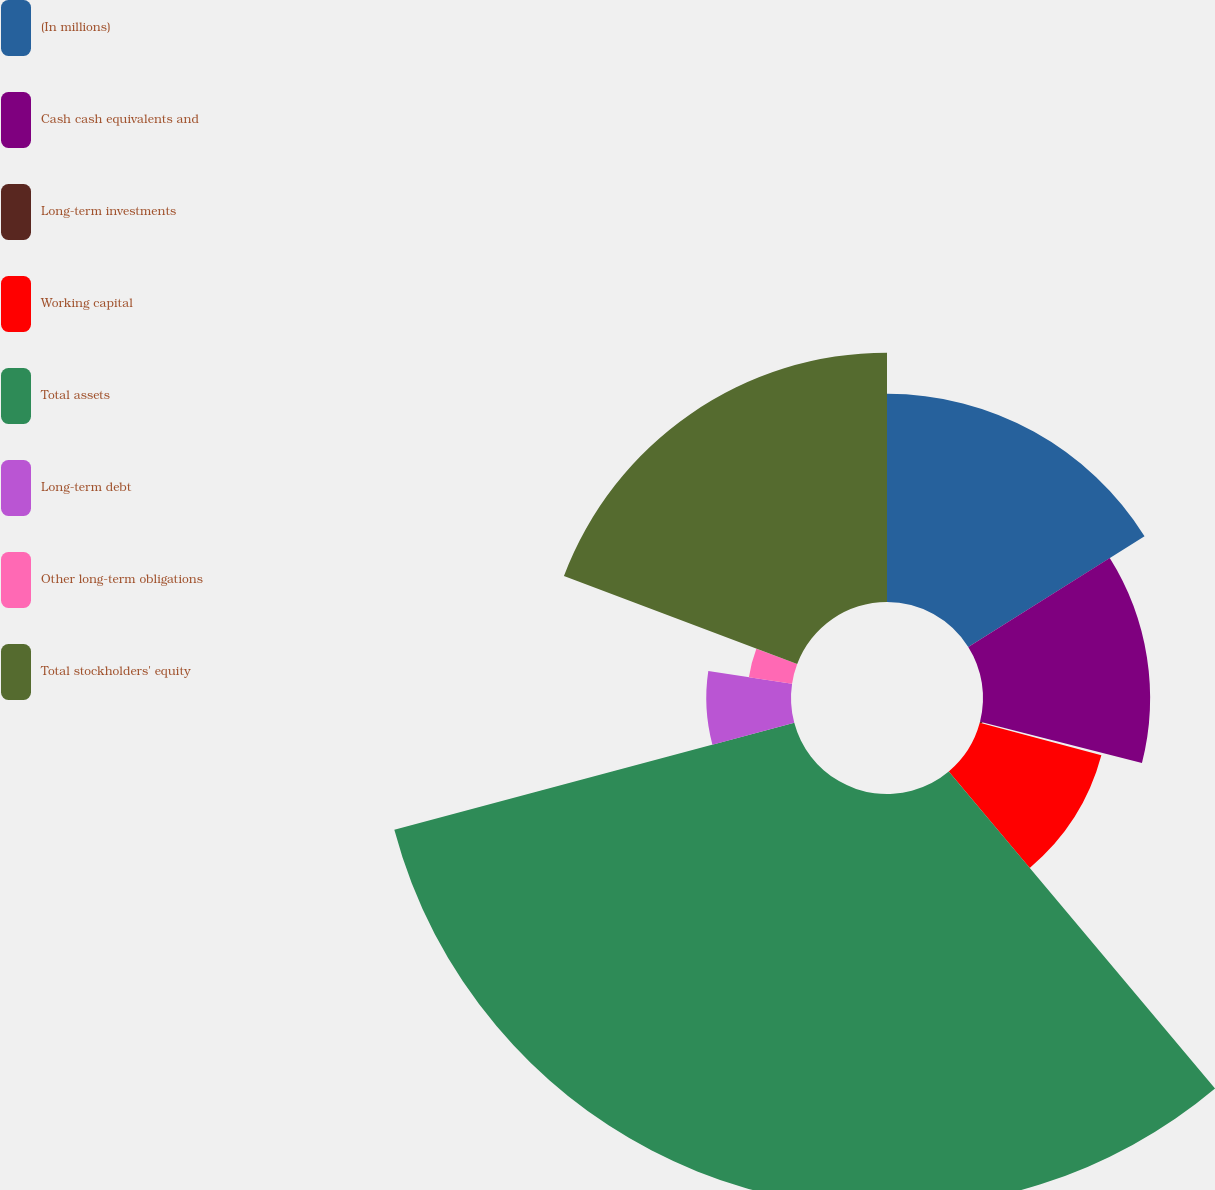<chart> <loc_0><loc_0><loc_500><loc_500><pie_chart><fcel>(In millions)<fcel>Cash cash equivalents and<fcel>Long-term investments<fcel>Working capital<fcel>Total assets<fcel>Long-term debt<fcel>Other long-term obligations<fcel>Total stockholders' equity<nl><fcel>16.07%<fcel>12.9%<fcel>0.19%<fcel>9.72%<fcel>31.96%<fcel>6.54%<fcel>3.37%<fcel>19.25%<nl></chart> 